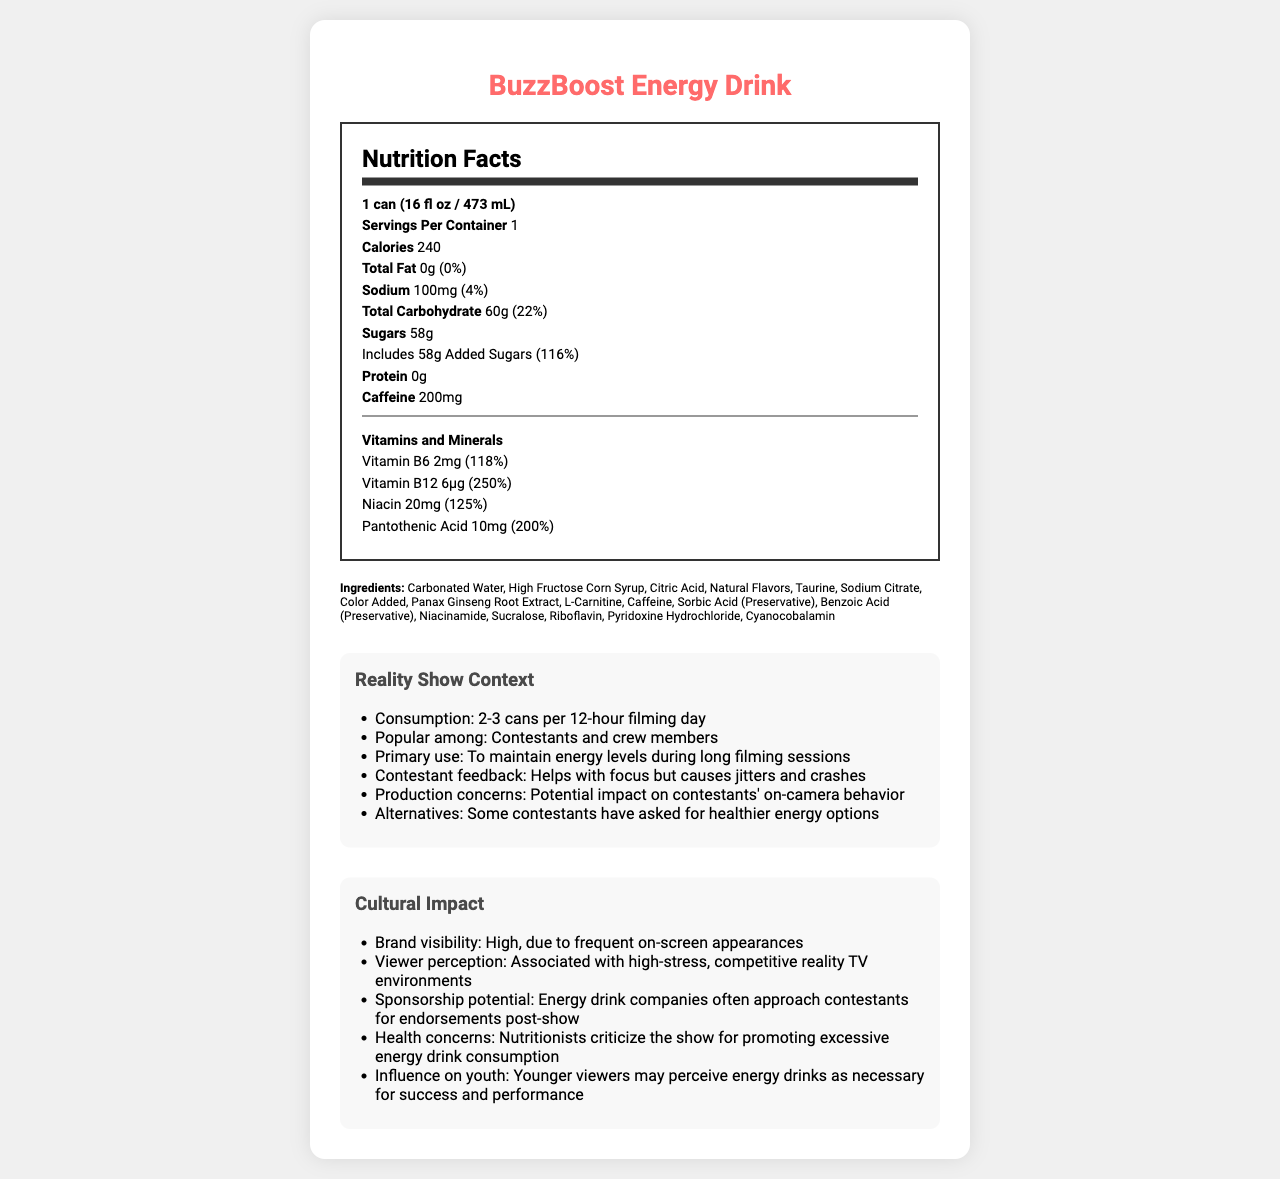how many calories does one can of BuzzBoost Energy Drink contain? The document states that one serving size, which is one can, contains 240 calories.
Answer: 240 what is the daily value percentage of sugars included in one can? The document indicates that one can includes 58g of sugars, which is 116% of the daily value.
Answer: 116% how much caffeine is in one can? The document lists that one can contains 200mg of caffeine.
Answer: 200mg name two vitamins included in the BuzzBoost Energy Drink and their daily value percentages. The vitamins and minerals section lists Vitamin B6 with a daily value of 118% and Vitamin B12 with a daily value of 250%.
Answer: Vitamin B6 (118%) and Vitamin B12 (250%) what is the primary use of BuzzBoost Energy Drink during filming sessions? Under the "Reality Show Context" section, it explains that the primary use is to maintain energy levels during long filming sessions.
Answer: To maintain energy levels during long filming sessions what are the main ingredients of BuzzBoost Energy Drink? A. Sugar, Water, Caffeine B. Carbonated Water, High Fructose Corn Syrup, Caffeine C. Sugar, Citric Acid, Sodium Citrate D. Natural Flavors, Taurine, Color Added The ingredient list specifies that Carbonated Water, High Fructose Corn Syrup, and Caffeine are main ingredients.
Answer: B. Carbonated Water, High Fructose Corn Syrup, Caffeine what is the serving size of BuzzBoost Energy Drink? A. 1 cup (240 mL) B. 2 cups (480 mL) C. 1 can (16 fl oz / 473 mL) The document specifies the serving size as 1 can (16 fl oz / 473 mL).
Answer: C. 1 can (16 fl oz / 473 mL) do contestants and crew members consume BuzzBoost Energy Drink regularly during filming? The document under "Reality Show Context" mentions that contestants and crew members consume 2-3 cans per 12-hour filming day, indicating regular consumption.
Answer: Yes summarize the main ideas presented in the document. The document provides detailed information about the nutritional content and ingredients of BuzzBoost Energy Drink, its consumption habits on a reality TV show, and its broader cultural impact and health concerns.
Answer: BuzzBoost Energy Drink's nutrition facts show it contains 240 calories and high levels of sugars and caffeine, and it is popular among reality TV show contestants and crew for maintaining energy. However, there are health concerns related to its consumption, particularly among youth viewers. what are the potential effects of consuming BuzzBoost Energy Drink on contestants' on-camera behavior? The document mentions production concerns about the potential impact but does not provide specific details on the effects on contestants' on-camera behavior.
Answer: Cannot be determined 